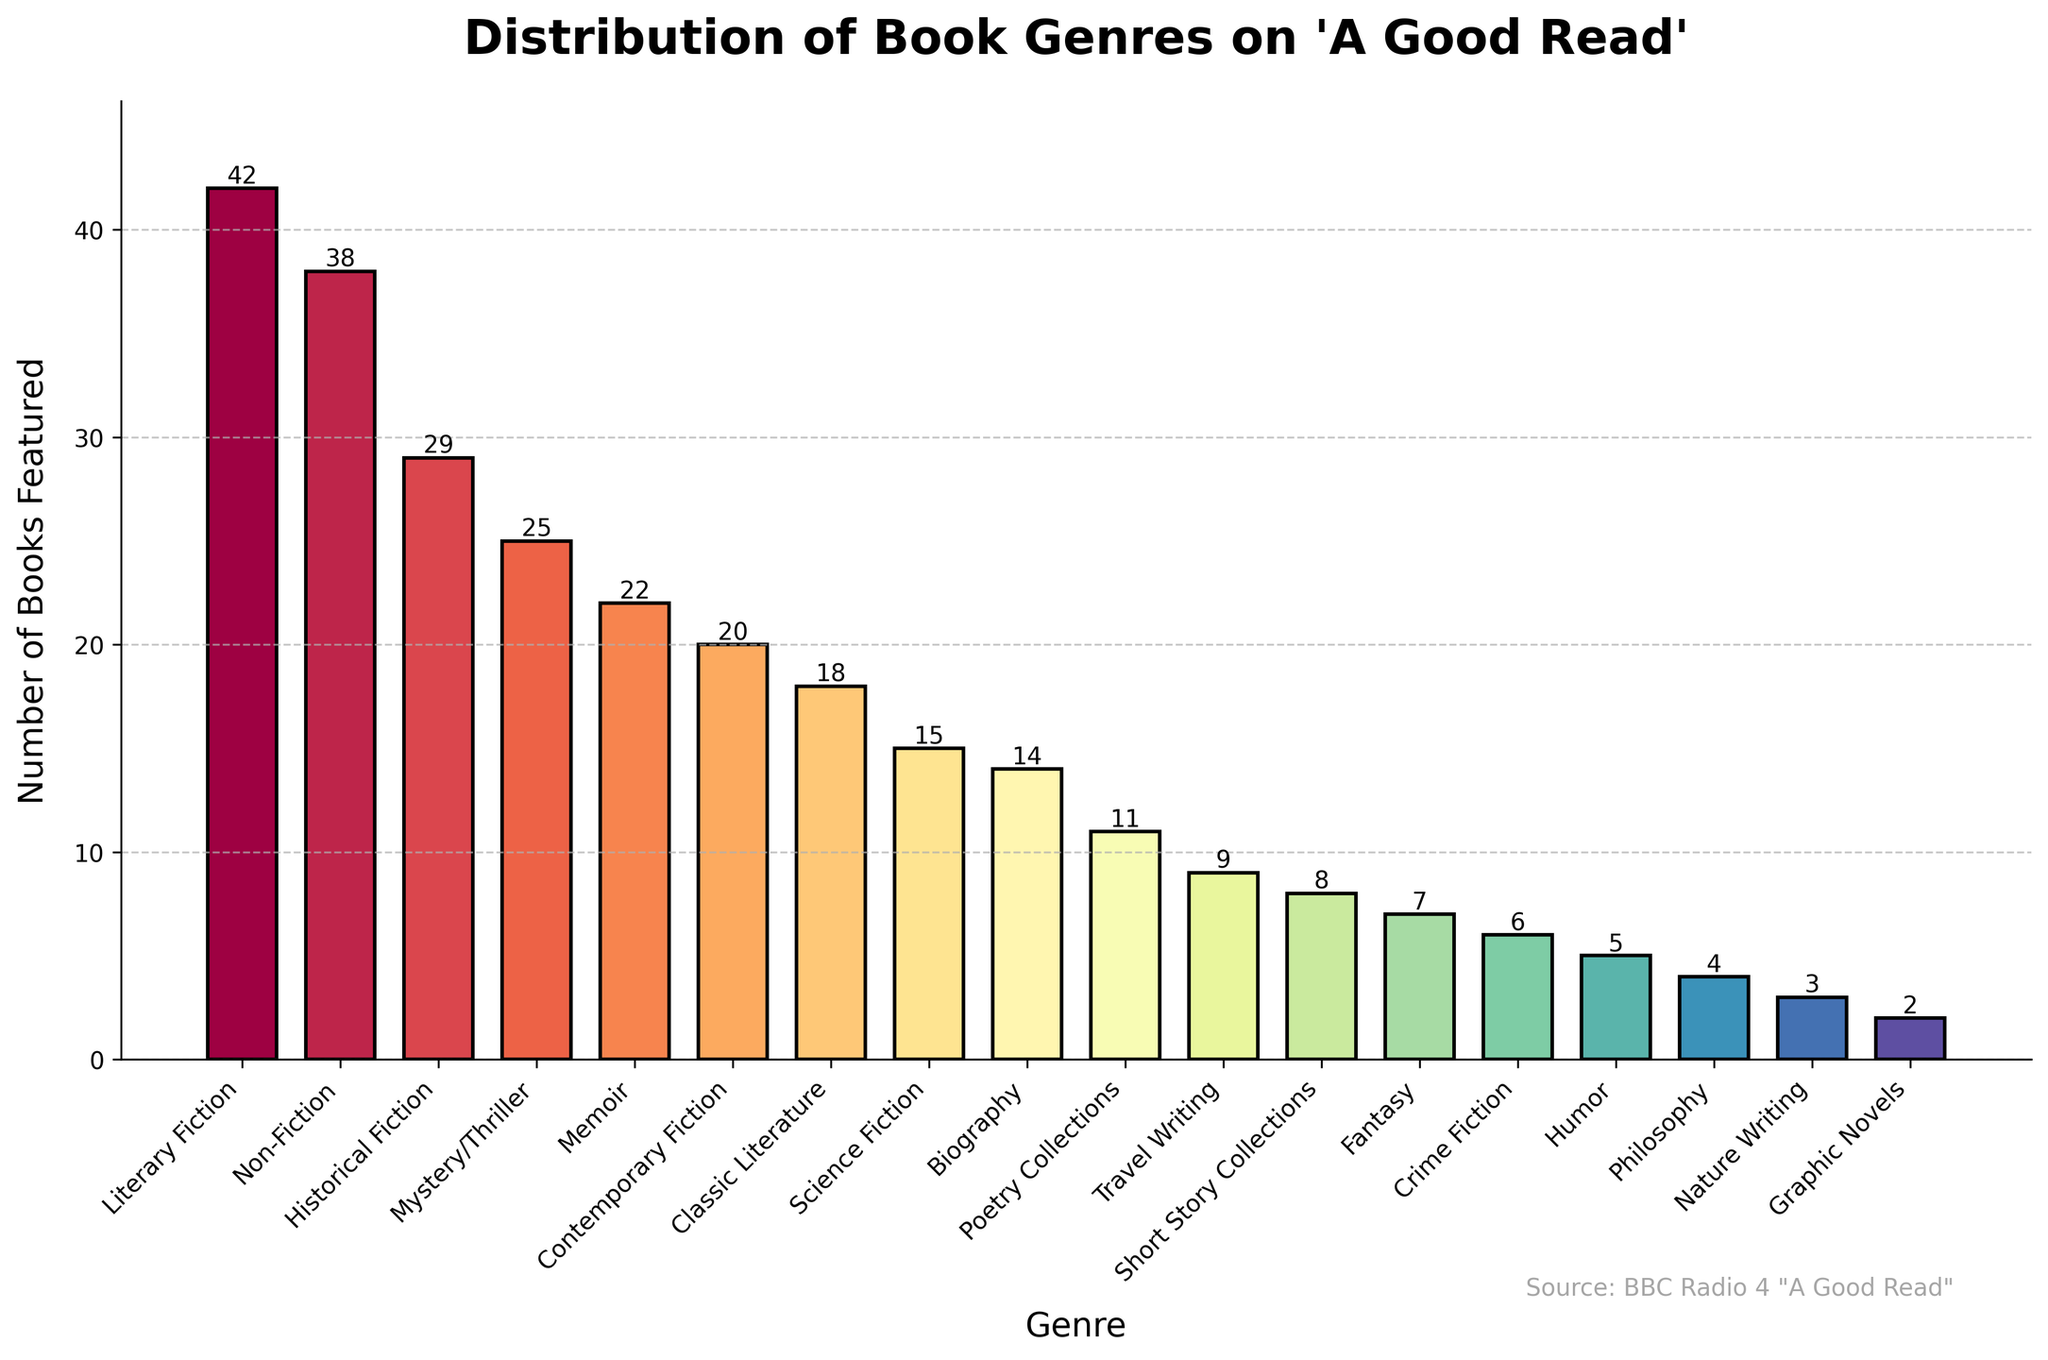Which genre has the highest number of books featured? The bar representing Literary Fiction is the tallest among all the genres, indicating that it has the highest number of books featured.
Answer: Literary Fiction How many more books feature in Literary Fiction compared to Science Fiction? Literary Fiction has 42 books featured, and Science Fiction has 15 books featured. The difference is 42 - 15.
Answer: 27 What is the total number of books featured for the genres of Memoir and Biography combined? Memoir has 22 books, and Biography has 14 books. Summing them gives 22 + 14.
Answer: 36 Which genre has fewer books featured, Poetry Collections or Graphic Novels? The bar for Poetry Collections is taller than the bar for Graphic Novels, indicating more books are featured in Poetry Collections.
Answer: Graphic Novels What is the average number of books featured for the top three genres? The top three genres are Literary Fiction (42), Non-Fiction (38), and Historical Fiction (29). The average is (42 + 38 + 29) / 3.
Answer: 36.33 How many genres have more than 20 books featured? Literary Fiction, Non-Fiction, Historical Fiction, Mystery/Thriller, and Memoir each have more than 20 books featured. Count of these genres is 5.
Answer: 5 Which genre has the smallest number of books featured? The bar for Graphic Novels is the shortest among all genres, indicating it has the smallest number of books featured.
Answer: Graphic Novels What is the difference between the number of books featured in Mystery/Thriller and Contemporary Fiction? Mystery/Thriller has 25 books, and Contemporary Fiction has 20 books. The difference is 25 - 20.
Answer: 5 How many genres have fewer than 10 books featured? Genres with fewer than 10 books featured are Travel Writing, Short Story Collections, Fantasy, Crime Fiction, Humor, Philosophy, Nature Writing, and Graphic Novels. There are 8 such genres.
Answer: 8 If the genres were grouped by fiction and non-fiction, which group would have more books featured? Grouping by fiction (Literary Fiction, Historical Fiction, Mystery/Thriller, Contemporary Fiction, Classic Literature, Science Fiction, Fantasy, Crime Fiction) and non-fiction (Non-Fiction, Memoir, Biography, Poetry Collections, Travel Writing, Philosophy, Nature Writing, Graphic Novels), fiction has higher counts (42 + 29 + 25 + 20 + 18 + 15 + 7 + 6) vs. non-fiction (38 + 22 + 14 + 11 + 9 + 4 + 3 + 2). Fiction totals 162, non-fiction totals 103.
Answer: Fiction 